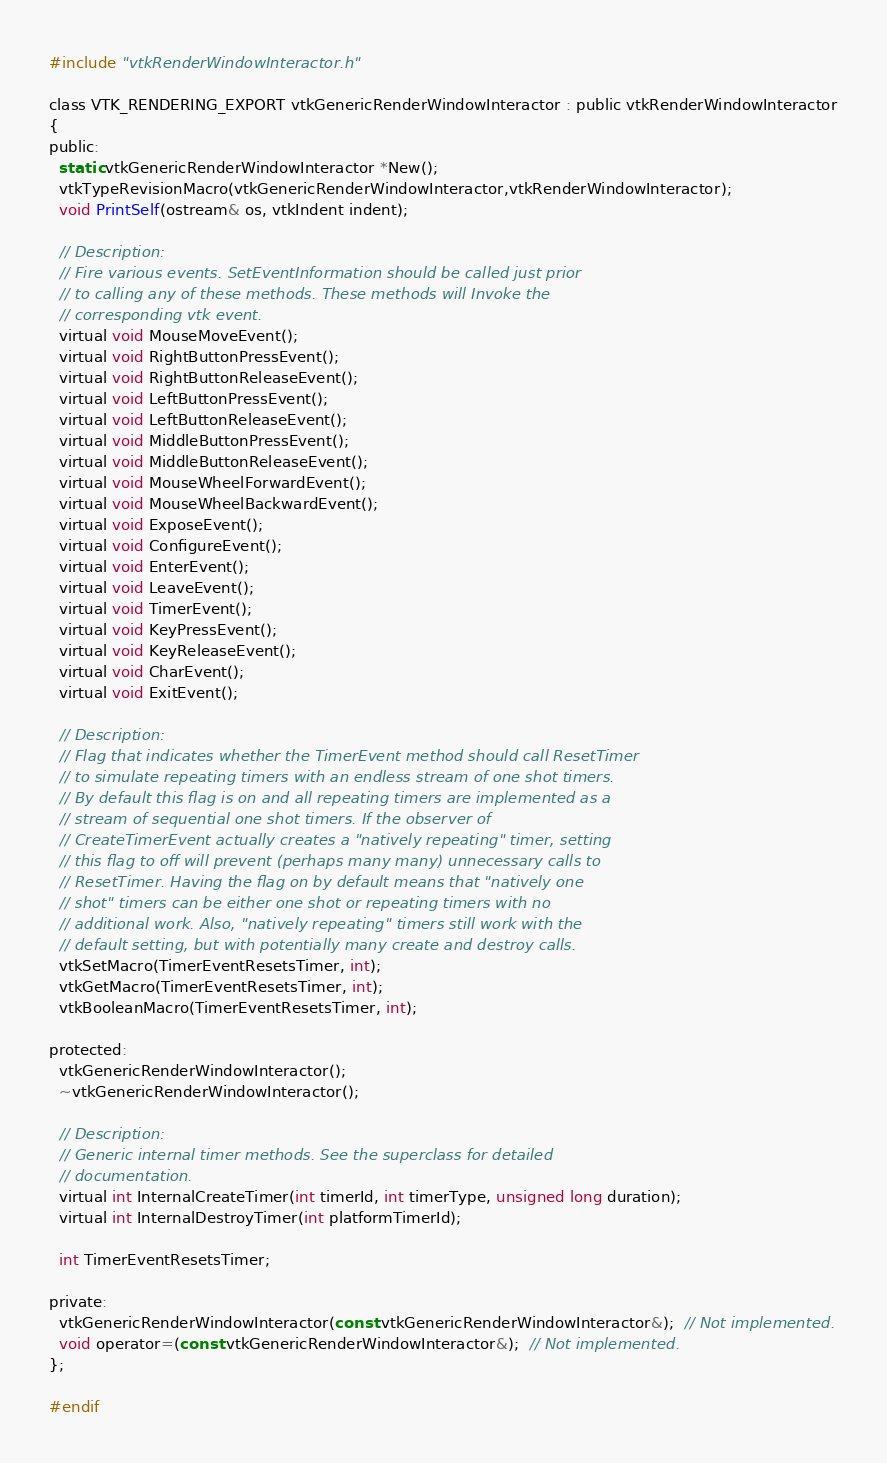Convert code to text. <code><loc_0><loc_0><loc_500><loc_500><_C_>
#include "vtkRenderWindowInteractor.h"

class VTK_RENDERING_EXPORT vtkGenericRenderWindowInteractor : public vtkRenderWindowInteractor
{
public:
  static vtkGenericRenderWindowInteractor *New();
  vtkTypeRevisionMacro(vtkGenericRenderWindowInteractor,vtkRenderWindowInteractor);
  void PrintSelf(ostream& os, vtkIndent indent);
  
  // Description:
  // Fire various events. SetEventInformation should be called just prior
  // to calling any of these methods. These methods will Invoke the
  // corresponding vtk event.
  virtual void MouseMoveEvent();
  virtual void RightButtonPressEvent();
  virtual void RightButtonReleaseEvent();
  virtual void LeftButtonPressEvent();
  virtual void LeftButtonReleaseEvent();
  virtual void MiddleButtonPressEvent();
  virtual void MiddleButtonReleaseEvent();
  virtual void MouseWheelForwardEvent();
  virtual void MouseWheelBackwardEvent();
  virtual void ExposeEvent();
  virtual void ConfigureEvent();
  virtual void EnterEvent();
  virtual void LeaveEvent();
  virtual void TimerEvent();
  virtual void KeyPressEvent();
  virtual void KeyReleaseEvent();
  virtual void CharEvent();
  virtual void ExitEvent();

  // Description:
  // Flag that indicates whether the TimerEvent method should call ResetTimer
  // to simulate repeating timers with an endless stream of one shot timers.
  // By default this flag is on and all repeating timers are implemented as a
  // stream of sequential one shot timers. If the observer of
  // CreateTimerEvent actually creates a "natively repeating" timer, setting
  // this flag to off will prevent (perhaps many many) unnecessary calls to
  // ResetTimer. Having the flag on by default means that "natively one
  // shot" timers can be either one shot or repeating timers with no
  // additional work. Also, "natively repeating" timers still work with the
  // default setting, but with potentially many create and destroy calls.
  vtkSetMacro(TimerEventResetsTimer, int);
  vtkGetMacro(TimerEventResetsTimer, int);
  vtkBooleanMacro(TimerEventResetsTimer, int);

protected:
  vtkGenericRenderWindowInteractor();
  ~vtkGenericRenderWindowInteractor();

  // Description: 
  // Generic internal timer methods. See the superclass for detailed
  // documentation.
  virtual int InternalCreateTimer(int timerId, int timerType, unsigned long duration);
  virtual int InternalDestroyTimer(int platformTimerId);

  int TimerEventResetsTimer;

private:
  vtkGenericRenderWindowInteractor(const vtkGenericRenderWindowInteractor&);  // Not implemented.
  void operator=(const vtkGenericRenderWindowInteractor&);  // Not implemented.
};

#endif
</code> 